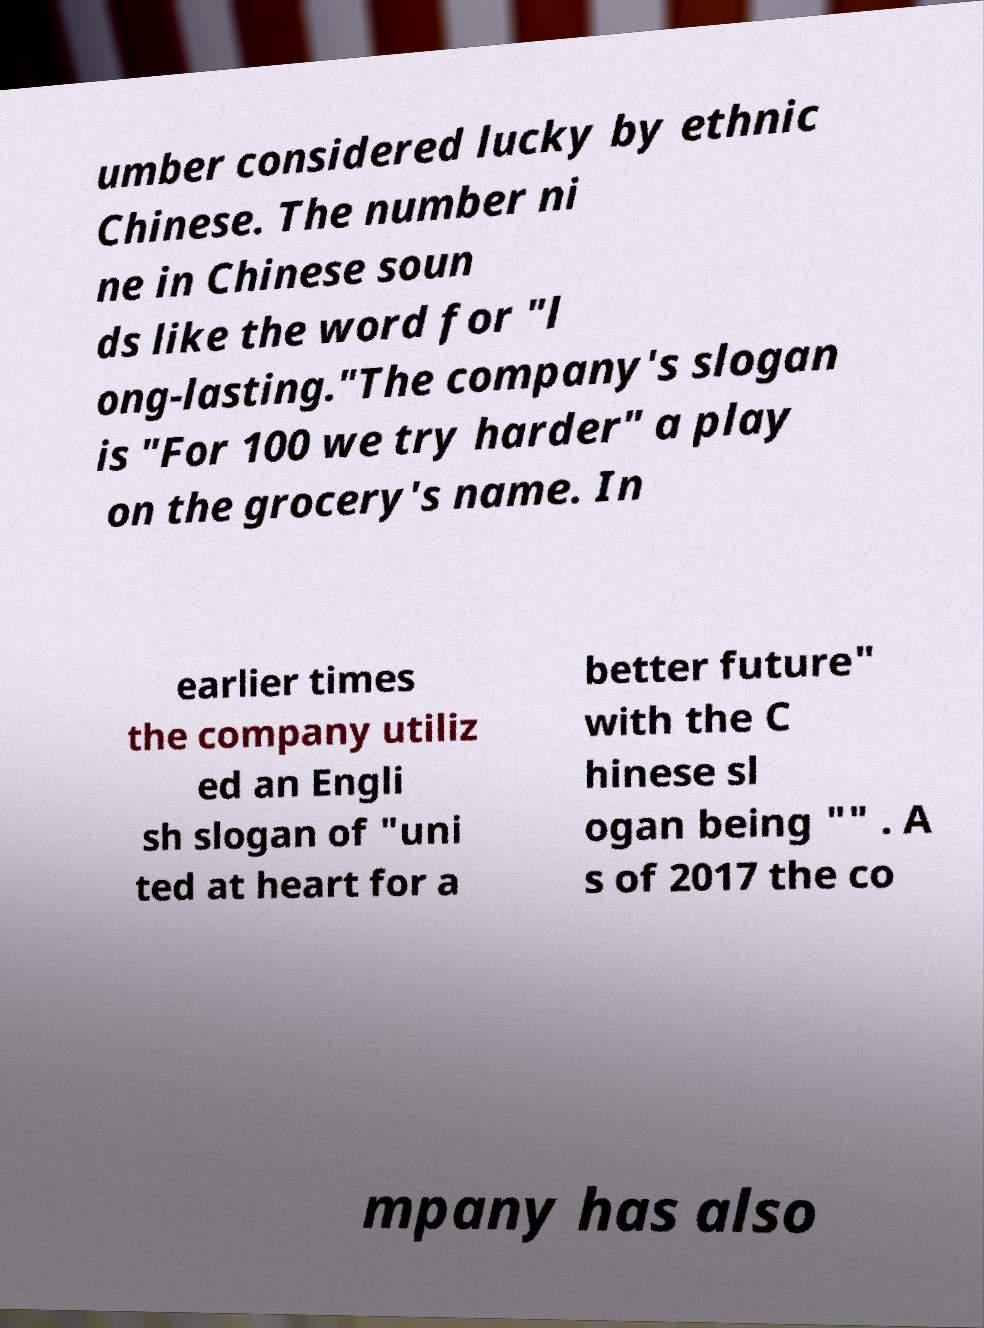Can you accurately transcribe the text from the provided image for me? umber considered lucky by ethnic Chinese. The number ni ne in Chinese soun ds like the word for "l ong-lasting."The company's slogan is "For 100 we try harder" a play on the grocery's name. In earlier times the company utiliz ed an Engli sh slogan of "uni ted at heart for a better future" with the C hinese sl ogan being "" . A s of 2017 the co mpany has also 